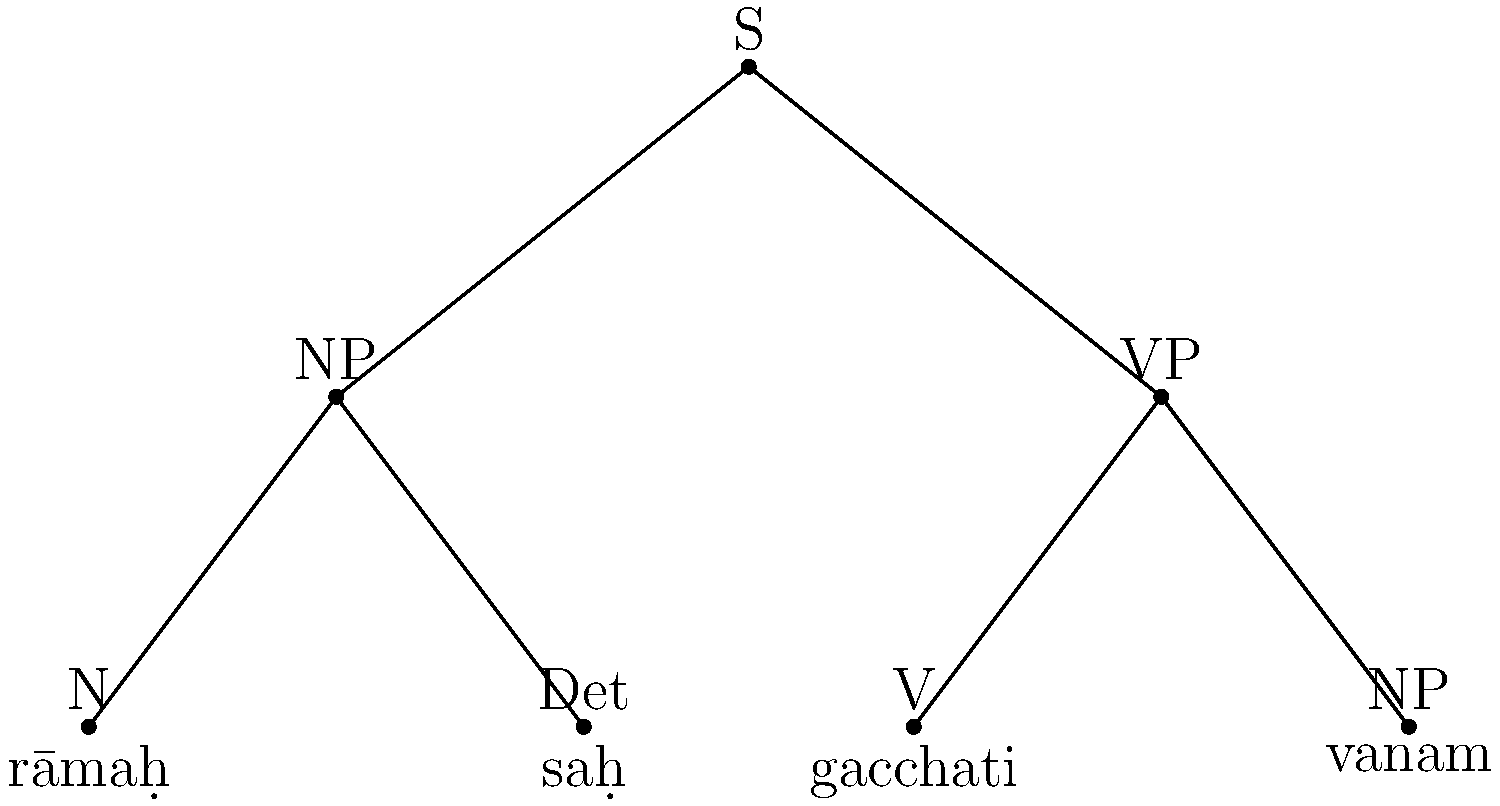Analyze the given tree diagram representing the syntactic structure of a Sanskrit sentence. What is the correct order of words in the sentence based on the diagram? To determine the correct order of words in the Sanskrit sentence based on the given tree diagram, we need to follow these steps:

1. Identify the main components of the sentence:
   - S (Sentence) is the root node
   - It branches into NP (Noun Phrase) and VP (Verb Phrase)

2. Analyze the NP (left branch):
   - NP consists of N (Noun) and Det (Determiner)
   - N is labeled "rāmaḥ"
   - Det is labeled "saḥ"
   - In Sanskrit, determiners usually follow the noun they modify

3. Analyze the VP (right branch):
   - VP consists of V (Verb) and NP (Noun Phrase)
   - V is labeled "gacchati"
   - The second NP contains only one element labeled "vanam"

4. Combine the elements in the correct order:
   - Start with the subject NP: "rāmaḥ saḥ"
   - Follow with the verb: "gacchati"
   - End with the object NP: "vanam"

5. The resulting sentence order is: "rāmaḥ saḥ gacchati vanam"

This order follows the typical Sanskrit sentence structure of Subject-Object-Verb (SOV), which is common in classical Sanskrit.
Answer: rāmaḥ saḥ gacchati vanam 